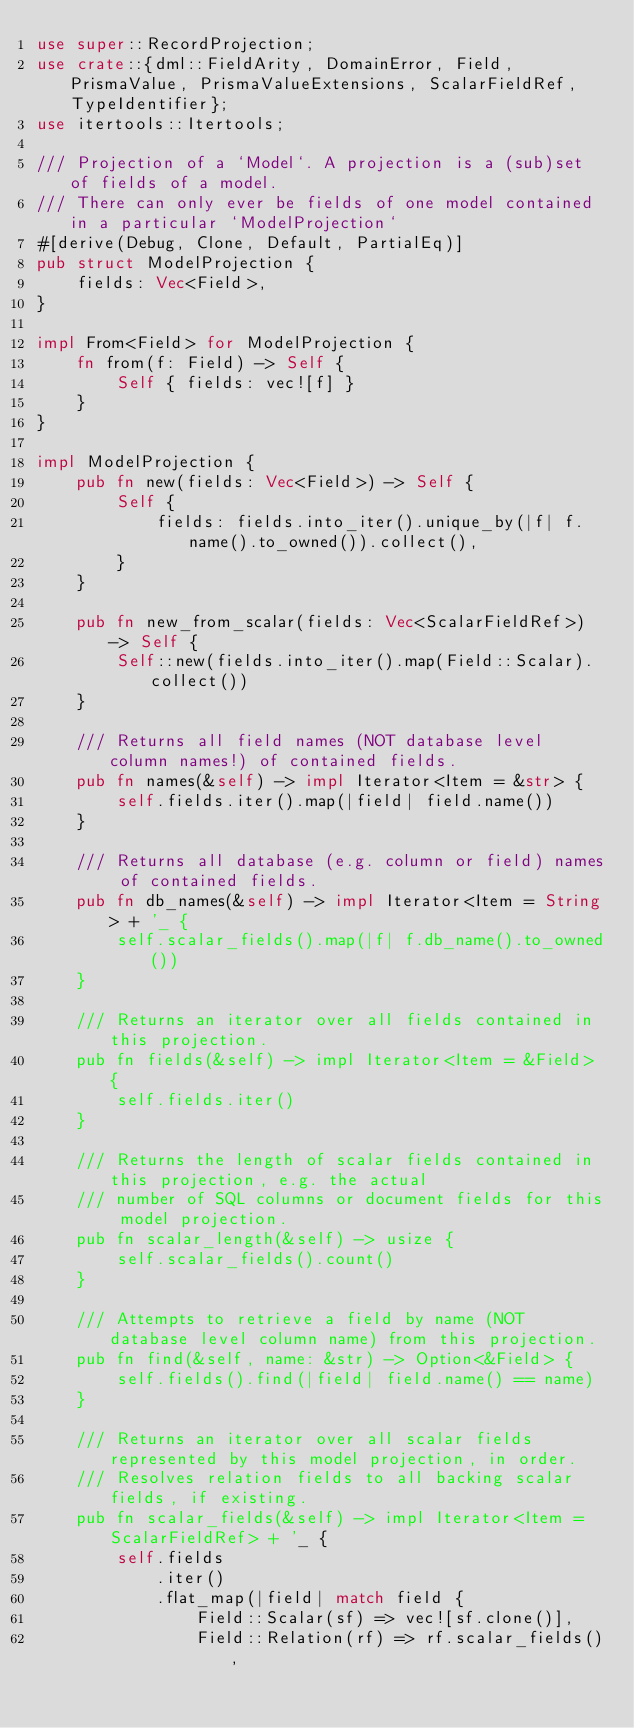Convert code to text. <code><loc_0><loc_0><loc_500><loc_500><_Rust_>use super::RecordProjection;
use crate::{dml::FieldArity, DomainError, Field, PrismaValue, PrismaValueExtensions, ScalarFieldRef, TypeIdentifier};
use itertools::Itertools;

/// Projection of a `Model`. A projection is a (sub)set of fields of a model.
/// There can only ever be fields of one model contained in a particular `ModelProjection`
#[derive(Debug, Clone, Default, PartialEq)]
pub struct ModelProjection {
    fields: Vec<Field>,
}

impl From<Field> for ModelProjection {
    fn from(f: Field) -> Self {
        Self { fields: vec![f] }
    }
}

impl ModelProjection {
    pub fn new(fields: Vec<Field>) -> Self {
        Self {
            fields: fields.into_iter().unique_by(|f| f.name().to_owned()).collect(),
        }
    }

    pub fn new_from_scalar(fields: Vec<ScalarFieldRef>) -> Self {
        Self::new(fields.into_iter().map(Field::Scalar).collect())
    }

    /// Returns all field names (NOT database level column names!) of contained fields.
    pub fn names(&self) -> impl Iterator<Item = &str> {
        self.fields.iter().map(|field| field.name())
    }

    /// Returns all database (e.g. column or field) names of contained fields.
    pub fn db_names(&self) -> impl Iterator<Item = String> + '_ {
        self.scalar_fields().map(|f| f.db_name().to_owned())
    }

    /// Returns an iterator over all fields contained in this projection.
    pub fn fields(&self) -> impl Iterator<Item = &Field> {
        self.fields.iter()
    }

    /// Returns the length of scalar fields contained in this projection, e.g. the actual
    /// number of SQL columns or document fields for this model projection.
    pub fn scalar_length(&self) -> usize {
        self.scalar_fields().count()
    }

    /// Attempts to retrieve a field by name (NOT database level column name) from this projection.
    pub fn find(&self, name: &str) -> Option<&Field> {
        self.fields().find(|field| field.name() == name)
    }

    /// Returns an iterator over all scalar fields represented by this model projection, in order.
    /// Resolves relation fields to all backing scalar fields, if existing.
    pub fn scalar_fields(&self) -> impl Iterator<Item = ScalarFieldRef> + '_ {
        self.fields
            .iter()
            .flat_map(|field| match field {
                Field::Scalar(sf) => vec![sf.clone()],
                Field::Relation(rf) => rf.scalar_fields(),</code> 